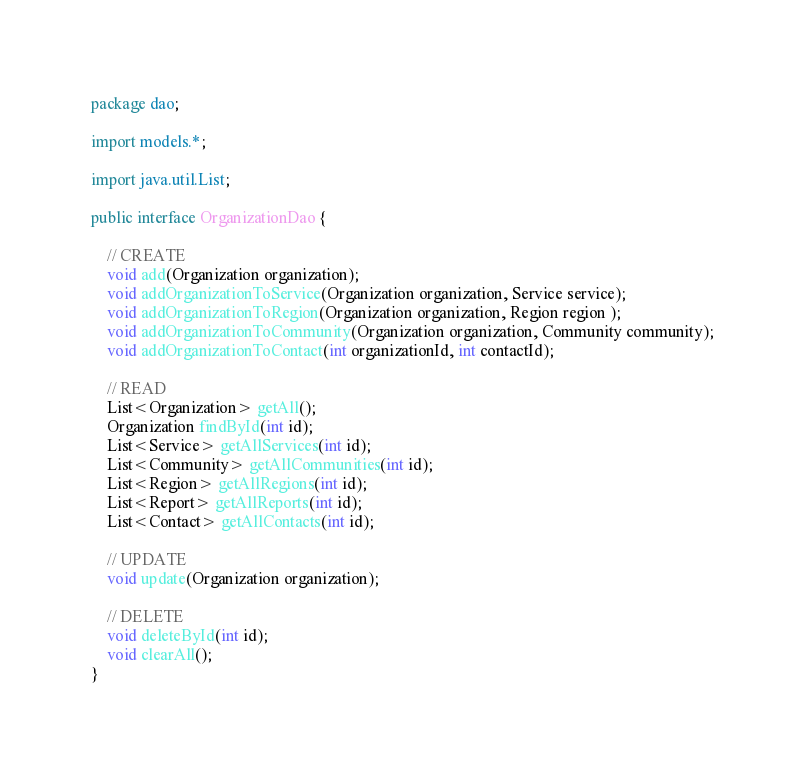Convert code to text. <code><loc_0><loc_0><loc_500><loc_500><_Java_>package dao;

import models.*;

import java.util.List;

public interface OrganizationDao {

    // CREATE
    void add(Organization organization);
    void addOrganizationToService(Organization organization, Service service);
    void addOrganizationToRegion(Organization organization, Region region );
    void addOrganizationToCommunity(Organization organization, Community community);
    void addOrganizationToContact(int organizationId, int contactId);

    // READ
    List<Organization> getAll();
    Organization findById(int id);
    List<Service> getAllServices(int id);
    List<Community> getAllCommunities(int id);
    List<Region> getAllRegions(int id);
    List<Report> getAllReports(int id);
    List<Contact> getAllContacts(int id);

    // UPDATE
    void update(Organization organization);

    // DELETE
    void deleteById(int id);
    void clearAll();
}
</code> 